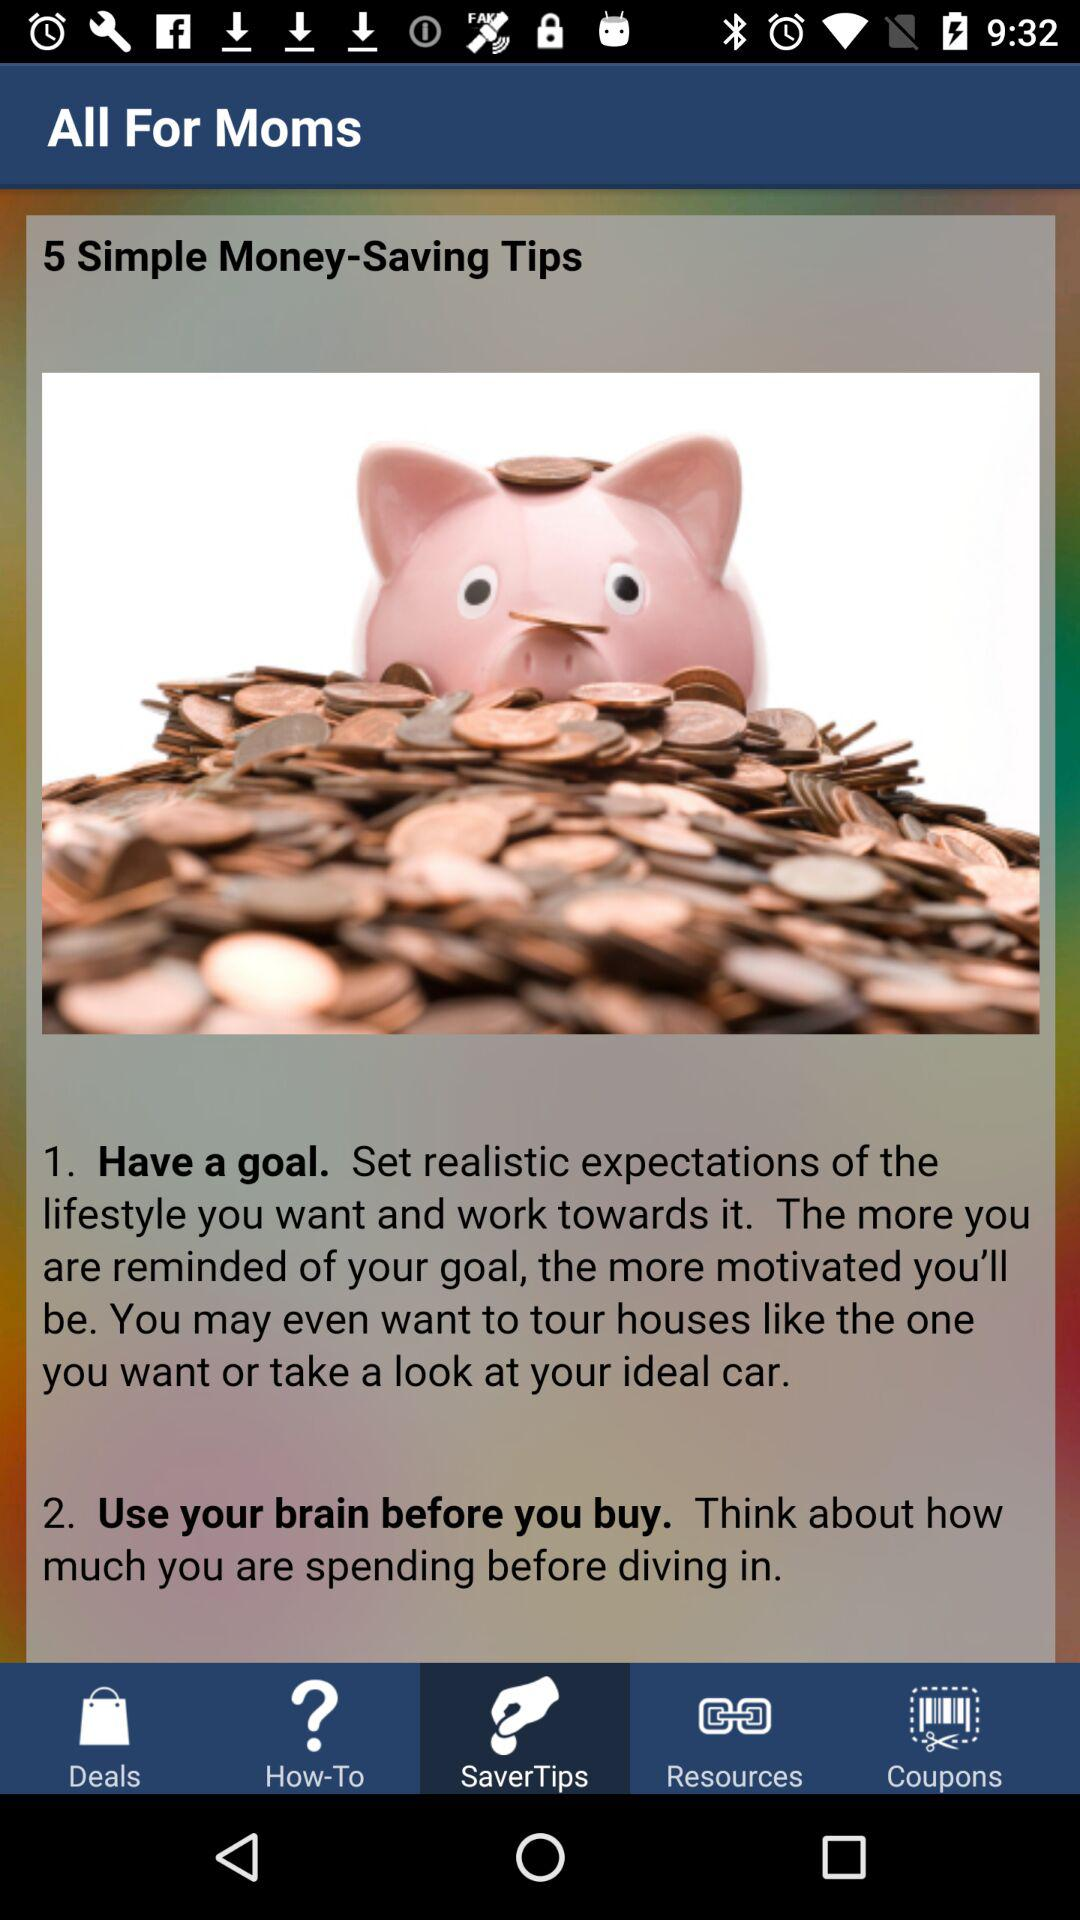How many tips in total are there to save money? There are a total of 5 tips to save money. 